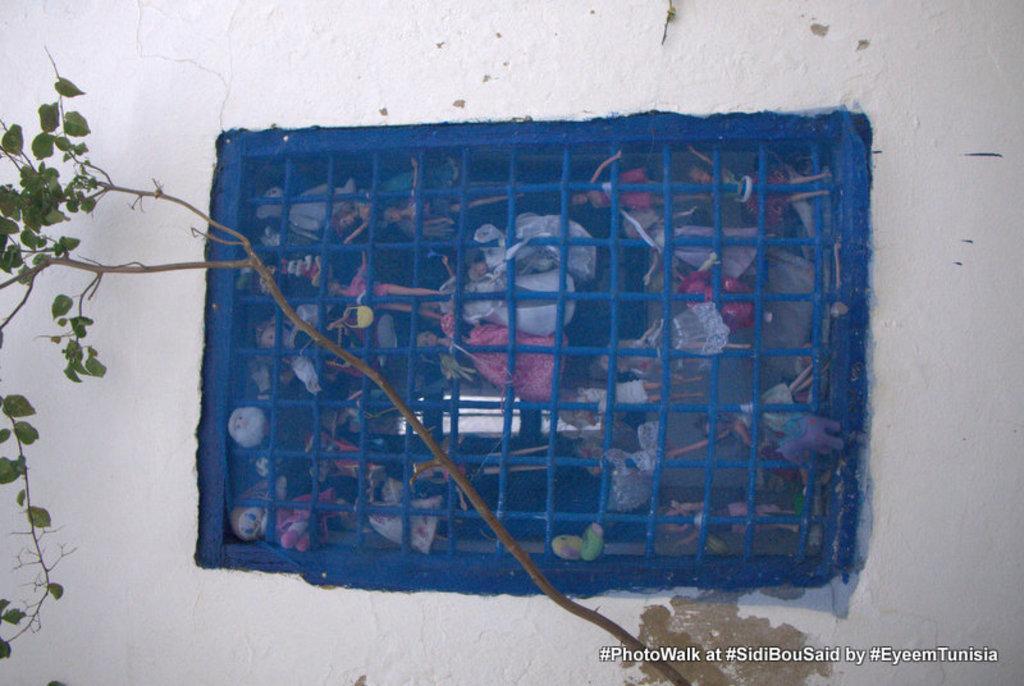How would you summarize this image in a sentence or two? In the center of the picture there is a window, inside the window there are toys. At the bottom there is a tree. In this picture there is a wall painted white. 